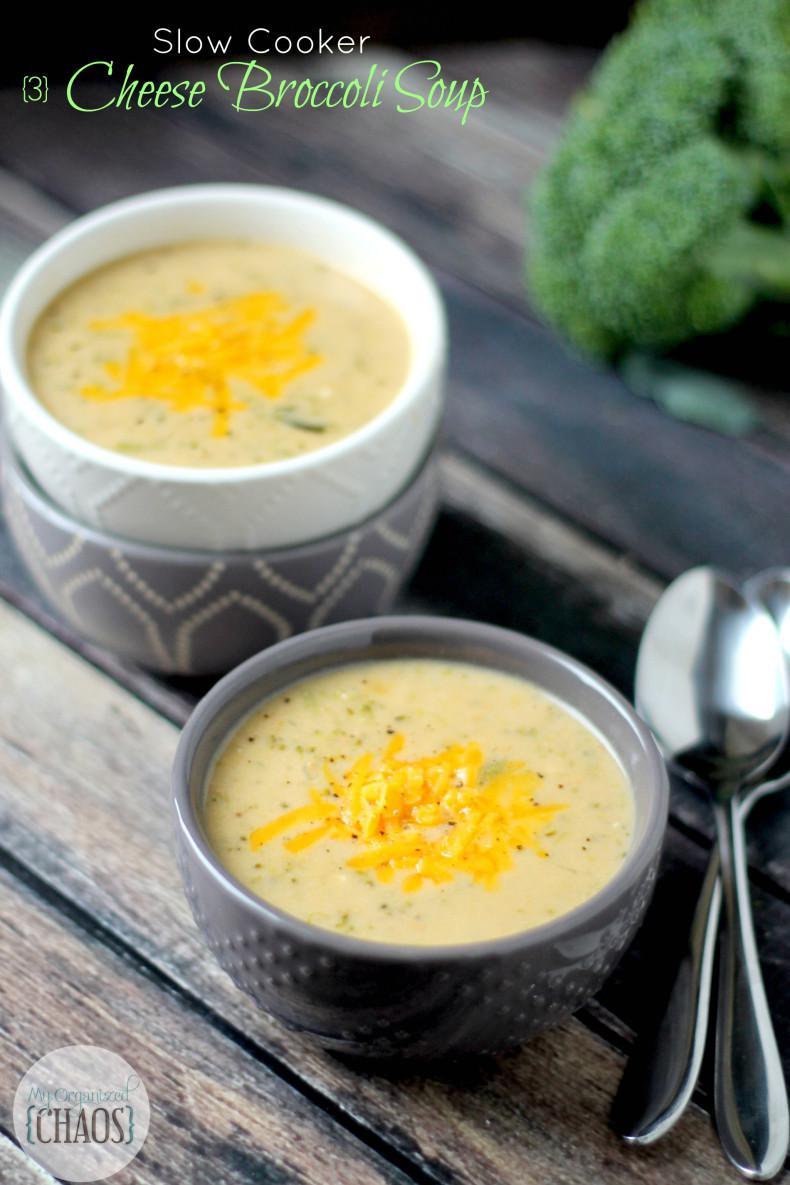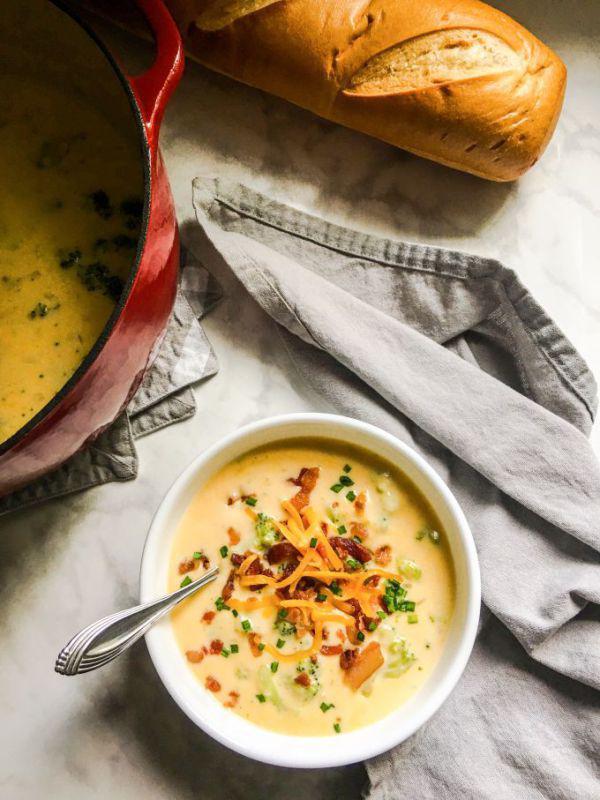The first image is the image on the left, the second image is the image on the right. Analyze the images presented: Is the assertion "there is exactly one bowl with a spoon in it in the image on the right" valid? Answer yes or no. Yes. The first image is the image on the left, the second image is the image on the right. Evaluate the accuracy of this statement regarding the images: "Right image shows creamy soup with colorful garnish and bread nearby.". Is it true? Answer yes or no. Yes. 